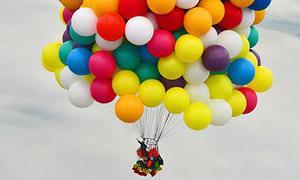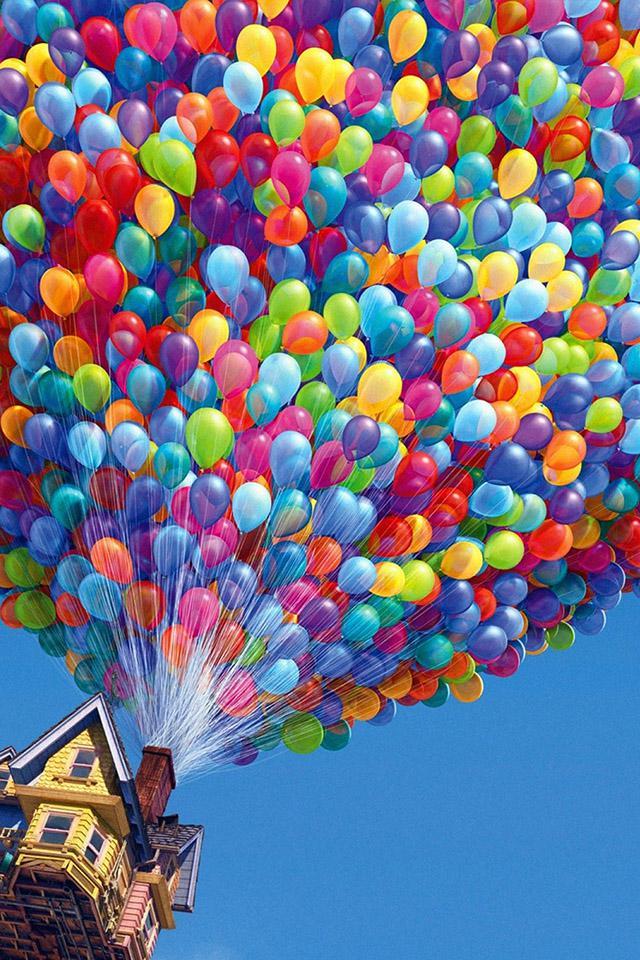The first image is the image on the left, the second image is the image on the right. Given the left and right images, does the statement "In at least one image there are many ballon made into one big balloon holding a house floating up and right." hold true? Answer yes or no. Yes. The first image is the image on the left, the second image is the image on the right. For the images shown, is this caption "Exactly one image shows a mass of balloons in the shape of a hot-air balloon, with their strings coming out of a chimney of a house, and the other image shows a bunch of balloons with no house attached under them." true? Answer yes or no. Yes. 